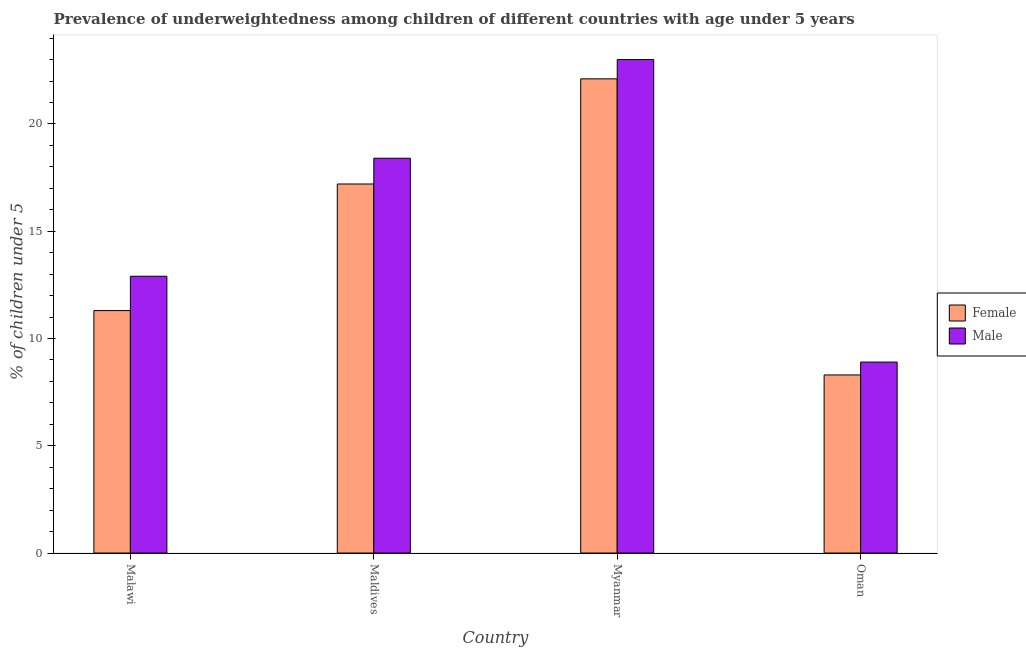How many different coloured bars are there?
Provide a short and direct response. 2. Are the number of bars per tick equal to the number of legend labels?
Provide a short and direct response. Yes. Are the number of bars on each tick of the X-axis equal?
Make the answer very short. Yes. What is the label of the 4th group of bars from the left?
Your answer should be compact. Oman. In how many cases, is the number of bars for a given country not equal to the number of legend labels?
Ensure brevity in your answer.  0. What is the percentage of underweighted male children in Oman?
Your answer should be compact. 8.9. Across all countries, what is the maximum percentage of underweighted female children?
Make the answer very short. 22.1. Across all countries, what is the minimum percentage of underweighted male children?
Your answer should be compact. 8.9. In which country was the percentage of underweighted female children maximum?
Provide a short and direct response. Myanmar. In which country was the percentage of underweighted female children minimum?
Offer a very short reply. Oman. What is the total percentage of underweighted male children in the graph?
Give a very brief answer. 63.2. What is the difference between the percentage of underweighted male children in Malawi and that in Myanmar?
Keep it short and to the point. -10.1. What is the difference between the percentage of underweighted female children in Oman and the percentage of underweighted male children in Myanmar?
Keep it short and to the point. -14.7. What is the average percentage of underweighted female children per country?
Your response must be concise. 14.73. What is the difference between the percentage of underweighted female children and percentage of underweighted male children in Oman?
Your answer should be very brief. -0.6. What is the ratio of the percentage of underweighted male children in Malawi to that in Maldives?
Give a very brief answer. 0.7. What is the difference between the highest and the second highest percentage of underweighted female children?
Ensure brevity in your answer.  4.9. What is the difference between the highest and the lowest percentage of underweighted female children?
Ensure brevity in your answer.  13.8. In how many countries, is the percentage of underweighted female children greater than the average percentage of underweighted female children taken over all countries?
Your response must be concise. 2. What does the 1st bar from the left in Maldives represents?
Your answer should be compact. Female. How many bars are there?
Your answer should be compact. 8. Are all the bars in the graph horizontal?
Your answer should be compact. No. Are the values on the major ticks of Y-axis written in scientific E-notation?
Your response must be concise. No. Does the graph contain any zero values?
Make the answer very short. No. Where does the legend appear in the graph?
Give a very brief answer. Center right. How many legend labels are there?
Offer a terse response. 2. What is the title of the graph?
Keep it short and to the point. Prevalence of underweightedness among children of different countries with age under 5 years. What is the label or title of the Y-axis?
Keep it short and to the point.  % of children under 5. What is the  % of children under 5 in Female in Malawi?
Your response must be concise. 11.3. What is the  % of children under 5 in Male in Malawi?
Offer a terse response. 12.9. What is the  % of children under 5 in Female in Maldives?
Keep it short and to the point. 17.2. What is the  % of children under 5 of Male in Maldives?
Keep it short and to the point. 18.4. What is the  % of children under 5 in Female in Myanmar?
Give a very brief answer. 22.1. What is the  % of children under 5 of Female in Oman?
Offer a terse response. 8.3. What is the  % of children under 5 in Male in Oman?
Provide a succinct answer. 8.9. Across all countries, what is the maximum  % of children under 5 in Female?
Ensure brevity in your answer.  22.1. Across all countries, what is the maximum  % of children under 5 of Male?
Offer a very short reply. 23. Across all countries, what is the minimum  % of children under 5 in Female?
Offer a very short reply. 8.3. Across all countries, what is the minimum  % of children under 5 of Male?
Make the answer very short. 8.9. What is the total  % of children under 5 of Female in the graph?
Your answer should be compact. 58.9. What is the total  % of children under 5 in Male in the graph?
Your answer should be compact. 63.2. What is the difference between the  % of children under 5 of Female in Malawi and that in Maldives?
Make the answer very short. -5.9. What is the difference between the  % of children under 5 of Female in Malawi and that in Myanmar?
Make the answer very short. -10.8. What is the difference between the  % of children under 5 in Female in Malawi and that in Oman?
Provide a short and direct response. 3. What is the difference between the  % of children under 5 in Female in Maldives and that in Myanmar?
Your answer should be very brief. -4.9. What is the difference between the  % of children under 5 of Male in Maldives and that in Myanmar?
Your answer should be very brief. -4.6. What is the difference between the  % of children under 5 of Female in Maldives and that in Oman?
Offer a very short reply. 8.9. What is the difference between the  % of children under 5 in Male in Myanmar and that in Oman?
Offer a terse response. 14.1. What is the difference between the  % of children under 5 in Female in Malawi and the  % of children under 5 in Male in Myanmar?
Give a very brief answer. -11.7. What is the difference between the  % of children under 5 of Female in Malawi and the  % of children under 5 of Male in Oman?
Provide a short and direct response. 2.4. What is the difference between the  % of children under 5 of Female in Myanmar and the  % of children under 5 of Male in Oman?
Your answer should be very brief. 13.2. What is the average  % of children under 5 in Female per country?
Offer a very short reply. 14.72. What is the average  % of children under 5 of Male per country?
Ensure brevity in your answer.  15.8. What is the difference between the  % of children under 5 of Female and  % of children under 5 of Male in Maldives?
Your response must be concise. -1.2. What is the ratio of the  % of children under 5 in Female in Malawi to that in Maldives?
Provide a succinct answer. 0.66. What is the ratio of the  % of children under 5 of Male in Malawi to that in Maldives?
Offer a terse response. 0.7. What is the ratio of the  % of children under 5 of Female in Malawi to that in Myanmar?
Provide a short and direct response. 0.51. What is the ratio of the  % of children under 5 in Male in Malawi to that in Myanmar?
Your answer should be compact. 0.56. What is the ratio of the  % of children under 5 of Female in Malawi to that in Oman?
Keep it short and to the point. 1.36. What is the ratio of the  % of children under 5 in Male in Malawi to that in Oman?
Provide a succinct answer. 1.45. What is the ratio of the  % of children under 5 of Female in Maldives to that in Myanmar?
Make the answer very short. 0.78. What is the ratio of the  % of children under 5 in Female in Maldives to that in Oman?
Your answer should be very brief. 2.07. What is the ratio of the  % of children under 5 in Male in Maldives to that in Oman?
Ensure brevity in your answer.  2.07. What is the ratio of the  % of children under 5 in Female in Myanmar to that in Oman?
Your answer should be very brief. 2.66. What is the ratio of the  % of children under 5 in Male in Myanmar to that in Oman?
Offer a very short reply. 2.58. What is the difference between the highest and the second highest  % of children under 5 of Male?
Your answer should be very brief. 4.6. 